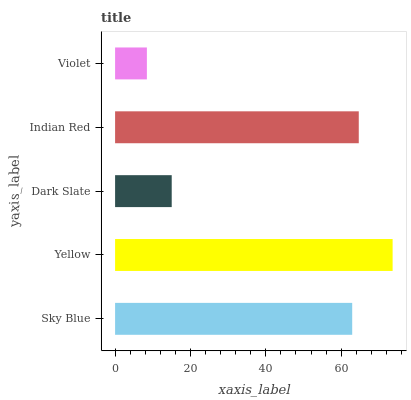Is Violet the minimum?
Answer yes or no. Yes. Is Yellow the maximum?
Answer yes or no. Yes. Is Dark Slate the minimum?
Answer yes or no. No. Is Dark Slate the maximum?
Answer yes or no. No. Is Yellow greater than Dark Slate?
Answer yes or no. Yes. Is Dark Slate less than Yellow?
Answer yes or no. Yes. Is Dark Slate greater than Yellow?
Answer yes or no. No. Is Yellow less than Dark Slate?
Answer yes or no. No. Is Sky Blue the high median?
Answer yes or no. Yes. Is Sky Blue the low median?
Answer yes or no. Yes. Is Indian Red the high median?
Answer yes or no. No. Is Violet the low median?
Answer yes or no. No. 